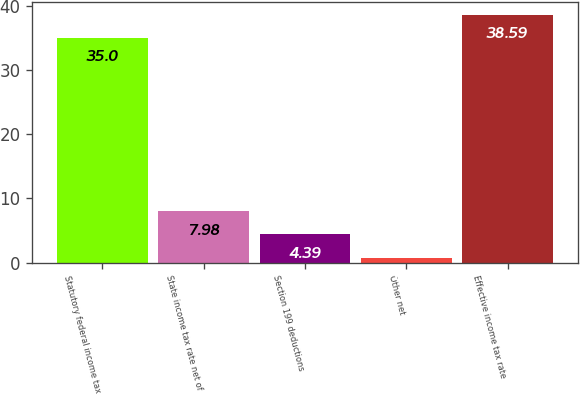Convert chart to OTSL. <chart><loc_0><loc_0><loc_500><loc_500><bar_chart><fcel>Statutory federal income tax<fcel>State income tax rate net of<fcel>Section 199 deductions<fcel>Other net<fcel>Effective income tax rate<nl><fcel>35<fcel>7.98<fcel>4.39<fcel>0.8<fcel>38.59<nl></chart> 